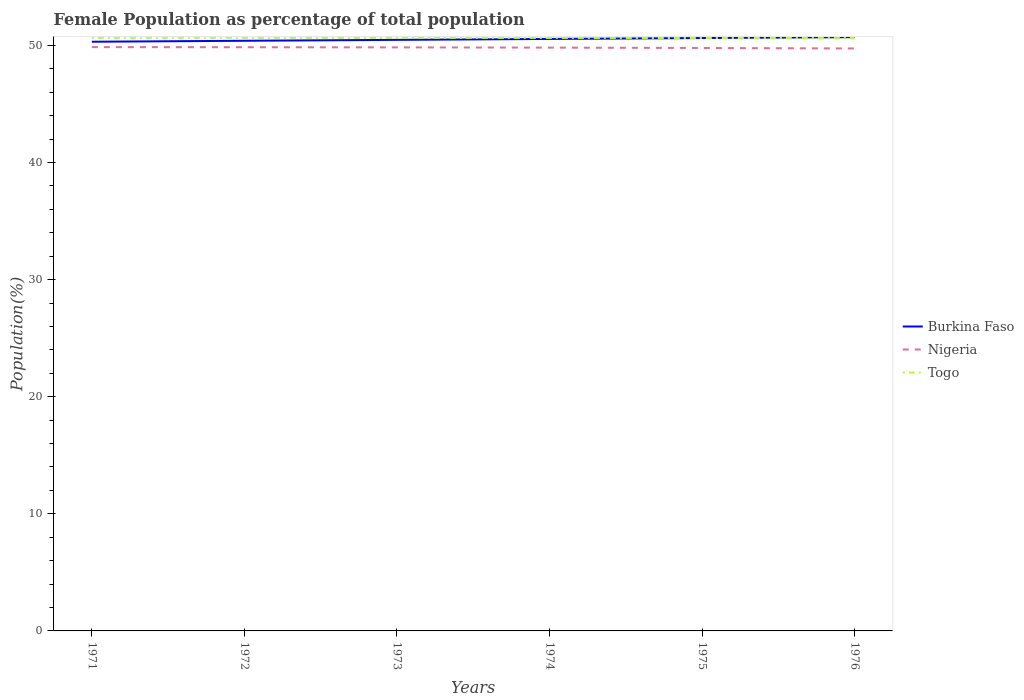Does the line corresponding to Nigeria intersect with the line corresponding to Togo?
Give a very brief answer. No. Across all years, what is the maximum female population in in Nigeria?
Your answer should be very brief. 49.73. In which year was the female population in in Nigeria maximum?
Give a very brief answer. 1976. What is the total female population in in Burkina Faso in the graph?
Your answer should be very brief. -0.08. What is the difference between the highest and the second highest female population in in Togo?
Provide a succinct answer. 0.02. What is the difference between the highest and the lowest female population in in Nigeria?
Provide a succinct answer. 4. How many lines are there?
Your answer should be compact. 3. Are the values on the major ticks of Y-axis written in scientific E-notation?
Your response must be concise. No. What is the title of the graph?
Ensure brevity in your answer.  Female Population as percentage of total population. Does "Denmark" appear as one of the legend labels in the graph?
Offer a terse response. No. What is the label or title of the X-axis?
Keep it short and to the point. Years. What is the label or title of the Y-axis?
Give a very brief answer. Population(%). What is the Population(%) of Burkina Faso in 1971?
Offer a very short reply. 50.31. What is the Population(%) in Nigeria in 1971?
Make the answer very short. 49.85. What is the Population(%) in Togo in 1971?
Your response must be concise. 50.65. What is the Population(%) in Burkina Faso in 1972?
Provide a short and direct response. 50.39. What is the Population(%) of Nigeria in 1972?
Offer a very short reply. 49.84. What is the Population(%) of Togo in 1972?
Ensure brevity in your answer.  50.64. What is the Population(%) in Burkina Faso in 1973?
Provide a short and direct response. 50.47. What is the Population(%) of Nigeria in 1973?
Give a very brief answer. 49.83. What is the Population(%) in Togo in 1973?
Provide a short and direct response. 50.64. What is the Population(%) in Burkina Faso in 1974?
Give a very brief answer. 50.55. What is the Population(%) of Nigeria in 1974?
Keep it short and to the point. 49.81. What is the Population(%) in Togo in 1974?
Keep it short and to the point. 50.63. What is the Population(%) in Burkina Faso in 1975?
Ensure brevity in your answer.  50.62. What is the Population(%) in Nigeria in 1975?
Keep it short and to the point. 49.78. What is the Population(%) in Togo in 1975?
Keep it short and to the point. 50.63. What is the Population(%) of Burkina Faso in 1976?
Your response must be concise. 50.7. What is the Population(%) in Nigeria in 1976?
Offer a terse response. 49.73. What is the Population(%) of Togo in 1976?
Make the answer very short. 50.62. Across all years, what is the maximum Population(%) in Burkina Faso?
Make the answer very short. 50.7. Across all years, what is the maximum Population(%) of Nigeria?
Provide a short and direct response. 49.85. Across all years, what is the maximum Population(%) of Togo?
Your answer should be very brief. 50.65. Across all years, what is the minimum Population(%) in Burkina Faso?
Offer a terse response. 50.31. Across all years, what is the minimum Population(%) in Nigeria?
Give a very brief answer. 49.73. Across all years, what is the minimum Population(%) in Togo?
Your answer should be compact. 50.62. What is the total Population(%) in Burkina Faso in the graph?
Your answer should be compact. 303.04. What is the total Population(%) in Nigeria in the graph?
Offer a terse response. 298.83. What is the total Population(%) of Togo in the graph?
Offer a terse response. 303.81. What is the difference between the Population(%) of Burkina Faso in 1971 and that in 1972?
Offer a very short reply. -0.08. What is the difference between the Population(%) of Nigeria in 1971 and that in 1972?
Provide a succinct answer. 0.01. What is the difference between the Population(%) in Togo in 1971 and that in 1972?
Make the answer very short. 0.01. What is the difference between the Population(%) in Burkina Faso in 1971 and that in 1973?
Your answer should be compact. -0.16. What is the difference between the Population(%) in Nigeria in 1971 and that in 1973?
Keep it short and to the point. 0.02. What is the difference between the Population(%) of Togo in 1971 and that in 1973?
Make the answer very short. 0.01. What is the difference between the Population(%) of Burkina Faso in 1971 and that in 1974?
Keep it short and to the point. -0.24. What is the difference between the Population(%) in Nigeria in 1971 and that in 1974?
Your answer should be very brief. 0.04. What is the difference between the Population(%) in Togo in 1971 and that in 1974?
Offer a very short reply. 0.01. What is the difference between the Population(%) in Burkina Faso in 1971 and that in 1975?
Offer a terse response. -0.32. What is the difference between the Population(%) of Nigeria in 1971 and that in 1975?
Offer a terse response. 0.07. What is the difference between the Population(%) of Togo in 1971 and that in 1975?
Offer a very short reply. 0.02. What is the difference between the Population(%) of Burkina Faso in 1971 and that in 1976?
Your answer should be compact. -0.39. What is the difference between the Population(%) in Nigeria in 1971 and that in 1976?
Offer a terse response. 0.11. What is the difference between the Population(%) of Togo in 1971 and that in 1976?
Give a very brief answer. 0.02. What is the difference between the Population(%) of Burkina Faso in 1972 and that in 1973?
Provide a short and direct response. -0.08. What is the difference between the Population(%) in Nigeria in 1972 and that in 1973?
Offer a very short reply. 0.01. What is the difference between the Population(%) in Togo in 1972 and that in 1973?
Provide a succinct answer. 0. What is the difference between the Population(%) of Burkina Faso in 1972 and that in 1974?
Keep it short and to the point. -0.16. What is the difference between the Population(%) of Nigeria in 1972 and that in 1974?
Your answer should be compact. 0.03. What is the difference between the Population(%) of Togo in 1972 and that in 1974?
Keep it short and to the point. 0.01. What is the difference between the Population(%) of Burkina Faso in 1972 and that in 1975?
Your answer should be very brief. -0.23. What is the difference between the Population(%) in Nigeria in 1972 and that in 1975?
Give a very brief answer. 0.06. What is the difference between the Population(%) of Togo in 1972 and that in 1975?
Ensure brevity in your answer.  0.01. What is the difference between the Population(%) of Burkina Faso in 1972 and that in 1976?
Offer a very short reply. -0.31. What is the difference between the Population(%) in Nigeria in 1972 and that in 1976?
Your response must be concise. 0.1. What is the difference between the Population(%) in Togo in 1972 and that in 1976?
Offer a terse response. 0.02. What is the difference between the Population(%) in Burkina Faso in 1973 and that in 1974?
Give a very brief answer. -0.08. What is the difference between the Population(%) in Nigeria in 1973 and that in 1974?
Offer a very short reply. 0.02. What is the difference between the Population(%) in Togo in 1973 and that in 1974?
Offer a terse response. 0. What is the difference between the Population(%) of Burkina Faso in 1973 and that in 1975?
Give a very brief answer. -0.16. What is the difference between the Population(%) of Nigeria in 1973 and that in 1975?
Ensure brevity in your answer.  0.05. What is the difference between the Population(%) of Togo in 1973 and that in 1975?
Provide a succinct answer. 0.01. What is the difference between the Population(%) of Burkina Faso in 1973 and that in 1976?
Give a very brief answer. -0.23. What is the difference between the Population(%) in Nigeria in 1973 and that in 1976?
Offer a very short reply. 0.09. What is the difference between the Population(%) in Togo in 1973 and that in 1976?
Ensure brevity in your answer.  0.01. What is the difference between the Population(%) of Burkina Faso in 1974 and that in 1975?
Provide a succinct answer. -0.08. What is the difference between the Population(%) of Nigeria in 1974 and that in 1975?
Your answer should be compact. 0.03. What is the difference between the Population(%) in Togo in 1974 and that in 1975?
Offer a terse response. 0. What is the difference between the Population(%) in Burkina Faso in 1974 and that in 1976?
Keep it short and to the point. -0.15. What is the difference between the Population(%) of Nigeria in 1974 and that in 1976?
Your response must be concise. 0.07. What is the difference between the Population(%) in Togo in 1974 and that in 1976?
Provide a short and direct response. 0.01. What is the difference between the Population(%) of Burkina Faso in 1975 and that in 1976?
Offer a very short reply. -0.08. What is the difference between the Population(%) of Nigeria in 1975 and that in 1976?
Provide a short and direct response. 0.04. What is the difference between the Population(%) of Togo in 1975 and that in 1976?
Offer a very short reply. 0. What is the difference between the Population(%) of Burkina Faso in 1971 and the Population(%) of Nigeria in 1972?
Your answer should be very brief. 0.47. What is the difference between the Population(%) in Burkina Faso in 1971 and the Population(%) in Togo in 1972?
Make the answer very short. -0.33. What is the difference between the Population(%) of Nigeria in 1971 and the Population(%) of Togo in 1972?
Keep it short and to the point. -0.79. What is the difference between the Population(%) of Burkina Faso in 1971 and the Population(%) of Nigeria in 1973?
Ensure brevity in your answer.  0.48. What is the difference between the Population(%) in Burkina Faso in 1971 and the Population(%) in Togo in 1973?
Offer a very short reply. -0.33. What is the difference between the Population(%) of Nigeria in 1971 and the Population(%) of Togo in 1973?
Your answer should be compact. -0.79. What is the difference between the Population(%) of Burkina Faso in 1971 and the Population(%) of Nigeria in 1974?
Offer a terse response. 0.5. What is the difference between the Population(%) in Burkina Faso in 1971 and the Population(%) in Togo in 1974?
Your response must be concise. -0.32. What is the difference between the Population(%) of Nigeria in 1971 and the Population(%) of Togo in 1974?
Your response must be concise. -0.78. What is the difference between the Population(%) in Burkina Faso in 1971 and the Population(%) in Nigeria in 1975?
Your answer should be very brief. 0.53. What is the difference between the Population(%) in Burkina Faso in 1971 and the Population(%) in Togo in 1975?
Give a very brief answer. -0.32. What is the difference between the Population(%) in Nigeria in 1971 and the Population(%) in Togo in 1975?
Provide a short and direct response. -0.78. What is the difference between the Population(%) of Burkina Faso in 1971 and the Population(%) of Nigeria in 1976?
Offer a terse response. 0.57. What is the difference between the Population(%) of Burkina Faso in 1971 and the Population(%) of Togo in 1976?
Your answer should be very brief. -0.31. What is the difference between the Population(%) of Nigeria in 1971 and the Population(%) of Togo in 1976?
Provide a succinct answer. -0.77. What is the difference between the Population(%) in Burkina Faso in 1972 and the Population(%) in Nigeria in 1973?
Provide a short and direct response. 0.56. What is the difference between the Population(%) of Burkina Faso in 1972 and the Population(%) of Togo in 1973?
Keep it short and to the point. -0.25. What is the difference between the Population(%) of Nigeria in 1972 and the Population(%) of Togo in 1973?
Your answer should be compact. -0.8. What is the difference between the Population(%) of Burkina Faso in 1972 and the Population(%) of Nigeria in 1974?
Your answer should be very brief. 0.58. What is the difference between the Population(%) in Burkina Faso in 1972 and the Population(%) in Togo in 1974?
Your answer should be compact. -0.24. What is the difference between the Population(%) in Nigeria in 1972 and the Population(%) in Togo in 1974?
Your response must be concise. -0.79. What is the difference between the Population(%) in Burkina Faso in 1972 and the Population(%) in Nigeria in 1975?
Give a very brief answer. 0.61. What is the difference between the Population(%) in Burkina Faso in 1972 and the Population(%) in Togo in 1975?
Your answer should be compact. -0.24. What is the difference between the Population(%) of Nigeria in 1972 and the Population(%) of Togo in 1975?
Give a very brief answer. -0.79. What is the difference between the Population(%) in Burkina Faso in 1972 and the Population(%) in Nigeria in 1976?
Give a very brief answer. 0.66. What is the difference between the Population(%) in Burkina Faso in 1972 and the Population(%) in Togo in 1976?
Give a very brief answer. -0.23. What is the difference between the Population(%) of Nigeria in 1972 and the Population(%) of Togo in 1976?
Your response must be concise. -0.78. What is the difference between the Population(%) in Burkina Faso in 1973 and the Population(%) in Nigeria in 1974?
Make the answer very short. 0.66. What is the difference between the Population(%) in Burkina Faso in 1973 and the Population(%) in Togo in 1974?
Make the answer very short. -0.16. What is the difference between the Population(%) in Nigeria in 1973 and the Population(%) in Togo in 1974?
Your answer should be very brief. -0.81. What is the difference between the Population(%) of Burkina Faso in 1973 and the Population(%) of Nigeria in 1975?
Provide a succinct answer. 0.69. What is the difference between the Population(%) in Burkina Faso in 1973 and the Population(%) in Togo in 1975?
Ensure brevity in your answer.  -0.16. What is the difference between the Population(%) in Nigeria in 1973 and the Population(%) in Togo in 1975?
Offer a terse response. -0.8. What is the difference between the Population(%) of Burkina Faso in 1973 and the Population(%) of Nigeria in 1976?
Offer a very short reply. 0.73. What is the difference between the Population(%) in Burkina Faso in 1973 and the Population(%) in Togo in 1976?
Your answer should be compact. -0.15. What is the difference between the Population(%) of Nigeria in 1973 and the Population(%) of Togo in 1976?
Provide a succinct answer. -0.8. What is the difference between the Population(%) of Burkina Faso in 1974 and the Population(%) of Nigeria in 1975?
Your response must be concise. 0.77. What is the difference between the Population(%) in Burkina Faso in 1974 and the Population(%) in Togo in 1975?
Your response must be concise. -0.08. What is the difference between the Population(%) in Nigeria in 1974 and the Population(%) in Togo in 1975?
Provide a succinct answer. -0.82. What is the difference between the Population(%) of Burkina Faso in 1974 and the Population(%) of Nigeria in 1976?
Offer a very short reply. 0.81. What is the difference between the Population(%) in Burkina Faso in 1974 and the Population(%) in Togo in 1976?
Your answer should be very brief. -0.08. What is the difference between the Population(%) in Nigeria in 1974 and the Population(%) in Togo in 1976?
Your answer should be very brief. -0.82. What is the difference between the Population(%) of Burkina Faso in 1975 and the Population(%) of Nigeria in 1976?
Provide a short and direct response. 0.89. What is the difference between the Population(%) in Burkina Faso in 1975 and the Population(%) in Togo in 1976?
Provide a succinct answer. 0. What is the difference between the Population(%) in Nigeria in 1975 and the Population(%) in Togo in 1976?
Give a very brief answer. -0.85. What is the average Population(%) of Burkina Faso per year?
Offer a terse response. 50.51. What is the average Population(%) of Nigeria per year?
Your answer should be very brief. 49.81. What is the average Population(%) in Togo per year?
Your answer should be compact. 50.64. In the year 1971, what is the difference between the Population(%) of Burkina Faso and Population(%) of Nigeria?
Offer a terse response. 0.46. In the year 1971, what is the difference between the Population(%) of Burkina Faso and Population(%) of Togo?
Offer a terse response. -0.34. In the year 1971, what is the difference between the Population(%) of Nigeria and Population(%) of Togo?
Offer a terse response. -0.8. In the year 1972, what is the difference between the Population(%) of Burkina Faso and Population(%) of Nigeria?
Make the answer very short. 0.55. In the year 1972, what is the difference between the Population(%) of Burkina Faso and Population(%) of Togo?
Keep it short and to the point. -0.25. In the year 1972, what is the difference between the Population(%) of Nigeria and Population(%) of Togo?
Give a very brief answer. -0.8. In the year 1973, what is the difference between the Population(%) of Burkina Faso and Population(%) of Nigeria?
Your answer should be very brief. 0.64. In the year 1973, what is the difference between the Population(%) of Burkina Faso and Population(%) of Togo?
Offer a terse response. -0.17. In the year 1973, what is the difference between the Population(%) in Nigeria and Population(%) in Togo?
Your answer should be compact. -0.81. In the year 1974, what is the difference between the Population(%) in Burkina Faso and Population(%) in Nigeria?
Provide a short and direct response. 0.74. In the year 1974, what is the difference between the Population(%) of Burkina Faso and Population(%) of Togo?
Your answer should be compact. -0.09. In the year 1974, what is the difference between the Population(%) in Nigeria and Population(%) in Togo?
Offer a terse response. -0.83. In the year 1975, what is the difference between the Population(%) in Burkina Faso and Population(%) in Nigeria?
Your answer should be very brief. 0.85. In the year 1975, what is the difference between the Population(%) in Burkina Faso and Population(%) in Togo?
Your answer should be very brief. -0. In the year 1975, what is the difference between the Population(%) in Nigeria and Population(%) in Togo?
Keep it short and to the point. -0.85. In the year 1976, what is the difference between the Population(%) in Burkina Faso and Population(%) in Nigeria?
Your answer should be compact. 0.97. In the year 1976, what is the difference between the Population(%) of Burkina Faso and Population(%) of Togo?
Your answer should be compact. 0.08. In the year 1976, what is the difference between the Population(%) of Nigeria and Population(%) of Togo?
Offer a very short reply. -0.89. What is the ratio of the Population(%) of Nigeria in 1971 to that in 1972?
Ensure brevity in your answer.  1. What is the ratio of the Population(%) in Togo in 1971 to that in 1972?
Give a very brief answer. 1. What is the ratio of the Population(%) of Burkina Faso in 1971 to that in 1973?
Provide a succinct answer. 1. What is the ratio of the Population(%) of Togo in 1971 to that in 1973?
Offer a very short reply. 1. What is the ratio of the Population(%) in Burkina Faso in 1971 to that in 1974?
Give a very brief answer. 1. What is the ratio of the Population(%) of Burkina Faso in 1971 to that in 1975?
Give a very brief answer. 0.99. What is the ratio of the Population(%) in Togo in 1971 to that in 1975?
Give a very brief answer. 1. What is the ratio of the Population(%) of Burkina Faso in 1971 to that in 1976?
Provide a short and direct response. 0.99. What is the ratio of the Population(%) in Togo in 1971 to that in 1976?
Your answer should be compact. 1. What is the ratio of the Population(%) of Nigeria in 1972 to that in 1973?
Your response must be concise. 1. What is the ratio of the Population(%) in Togo in 1972 to that in 1973?
Provide a short and direct response. 1. What is the ratio of the Population(%) of Burkina Faso in 1972 to that in 1974?
Your answer should be compact. 1. What is the ratio of the Population(%) in Togo in 1972 to that in 1974?
Your answer should be compact. 1. What is the ratio of the Population(%) of Burkina Faso in 1972 to that in 1975?
Provide a succinct answer. 1. What is the ratio of the Population(%) in Togo in 1972 to that in 1975?
Give a very brief answer. 1. What is the ratio of the Population(%) in Nigeria in 1972 to that in 1976?
Make the answer very short. 1. What is the ratio of the Population(%) in Togo in 1972 to that in 1976?
Make the answer very short. 1. What is the ratio of the Population(%) of Burkina Faso in 1973 to that in 1975?
Provide a short and direct response. 1. What is the ratio of the Population(%) in Nigeria in 1973 to that in 1975?
Keep it short and to the point. 1. What is the ratio of the Population(%) of Burkina Faso in 1973 to that in 1976?
Your answer should be very brief. 1. What is the ratio of the Population(%) in Togo in 1973 to that in 1976?
Offer a very short reply. 1. What is the ratio of the Population(%) of Burkina Faso in 1974 to that in 1975?
Keep it short and to the point. 1. What is the ratio of the Population(%) in Togo in 1974 to that in 1975?
Your answer should be very brief. 1. What is the ratio of the Population(%) of Nigeria in 1974 to that in 1976?
Your answer should be compact. 1. What is the difference between the highest and the second highest Population(%) of Burkina Faso?
Your response must be concise. 0.08. What is the difference between the highest and the second highest Population(%) of Nigeria?
Your answer should be compact. 0.01. What is the difference between the highest and the second highest Population(%) of Togo?
Offer a very short reply. 0.01. What is the difference between the highest and the lowest Population(%) of Burkina Faso?
Ensure brevity in your answer.  0.39. What is the difference between the highest and the lowest Population(%) in Nigeria?
Your answer should be compact. 0.11. What is the difference between the highest and the lowest Population(%) of Togo?
Your response must be concise. 0.02. 